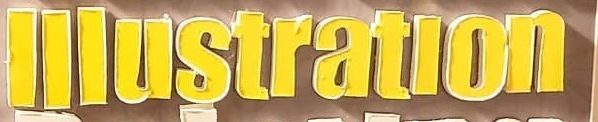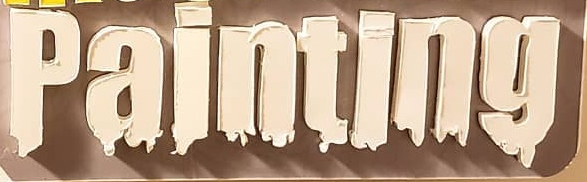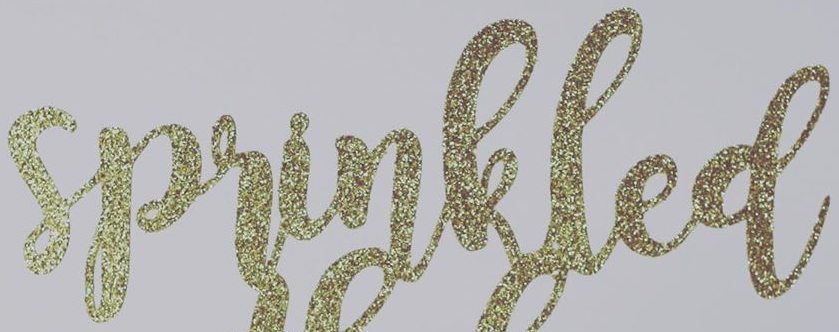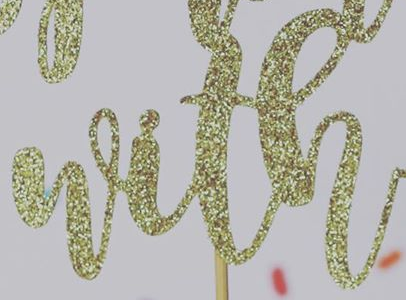Identify the words shown in these images in order, separated by a semicolon. lllustratlon; painting; sprinkled; with 